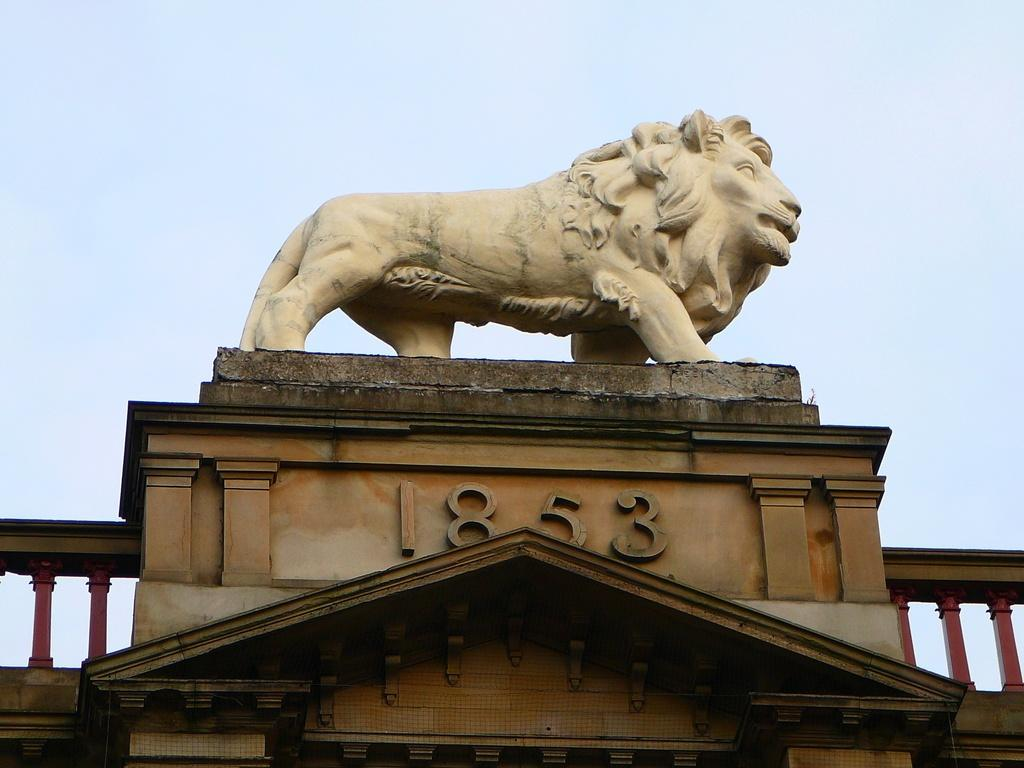What is the main subject of the image? The main subject of the image is a statue of a lion. Where is the statue located? The statue is on a building. Is there any additional information about the statue or its location? Yes, the year 1853 is written below the statue. Reasoning: Let's think step by identifying the main subject of the image, which is the statue of a lion. Then, we describe its location, which is on a building. Finally, we mention the additional detail of the year 1853 written below the statue. Each question is designed to elicit a specific detail about the image that is known from the provided facts. Absurd Question/Answer: What type of record does the lion hold in its paws in the image? There is no record present in the image, and the lion is not holding anything in its paws. 